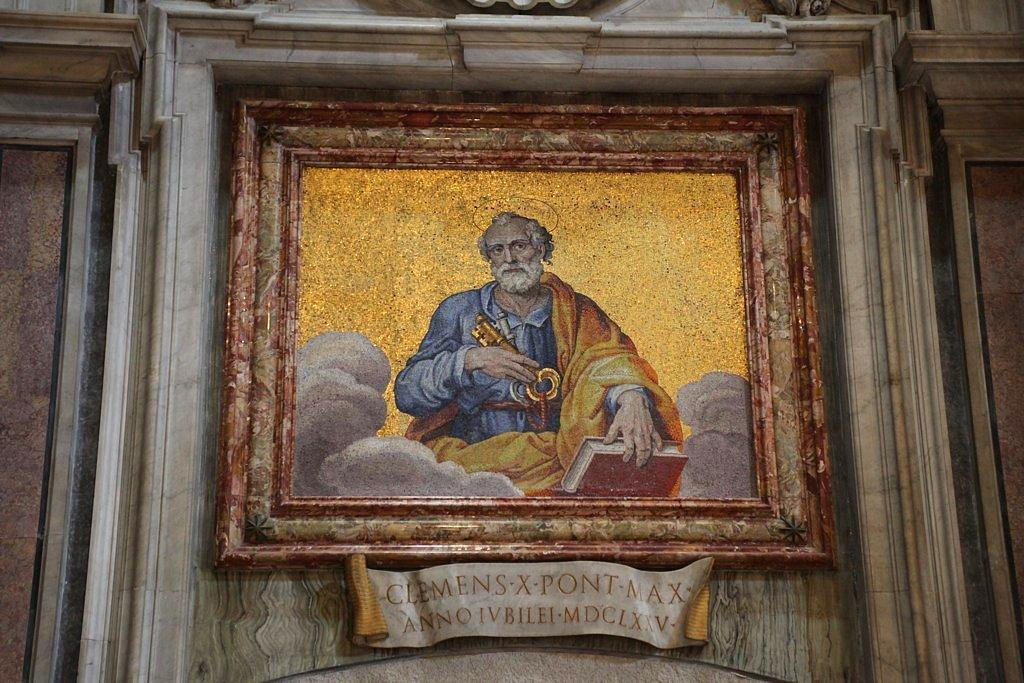<image>
Write a terse but informative summary of the picture. Picture framed of a man and the words "Clemens X Pont Max" under it. 